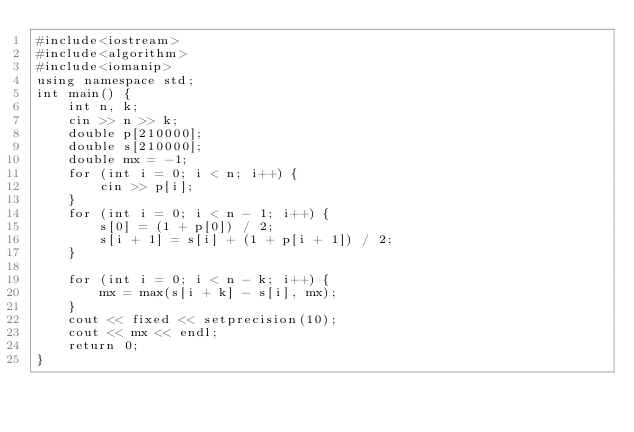<code> <loc_0><loc_0><loc_500><loc_500><_C++_>#include<iostream>
#include<algorithm>
#include<iomanip>
using namespace std;
int main() {
	int n, k;
	cin >> n >> k;
	double p[210000];
	double s[210000];
	double mx = -1;
	for (int i = 0; i < n; i++) {
		cin >> p[i];
	}
	for (int i = 0; i < n - 1; i++) {
		s[0] = (1 + p[0]) / 2;
		s[i + 1] = s[i] + (1 + p[i + 1]) / 2;
	}
		
	for (int i = 0; i < n - k; i++) {
		mx = max(s[i + k] - s[i], mx);
	}
	cout << fixed << setprecision(10);
	cout << mx << endl;
	return 0;
}
</code> 